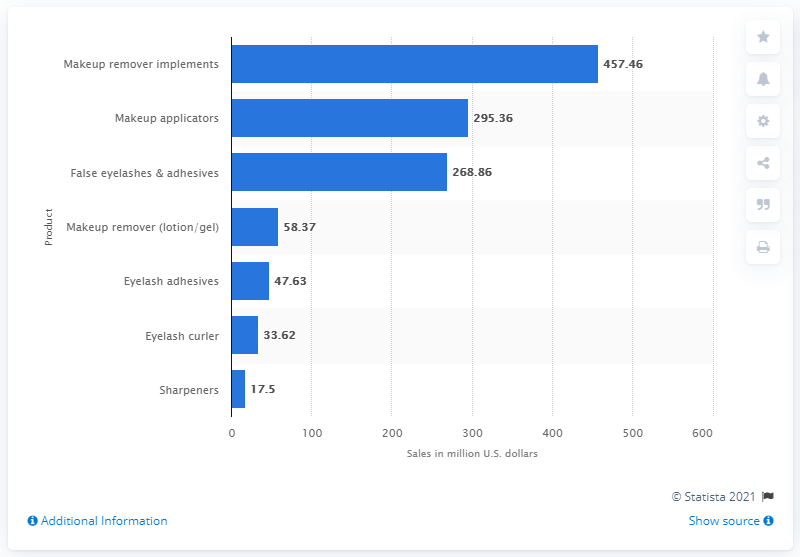Outline some significant characteristics in this image. In 2019, the retail sales of makeup applicator products in the United States totaled 295.36 million dollars. 